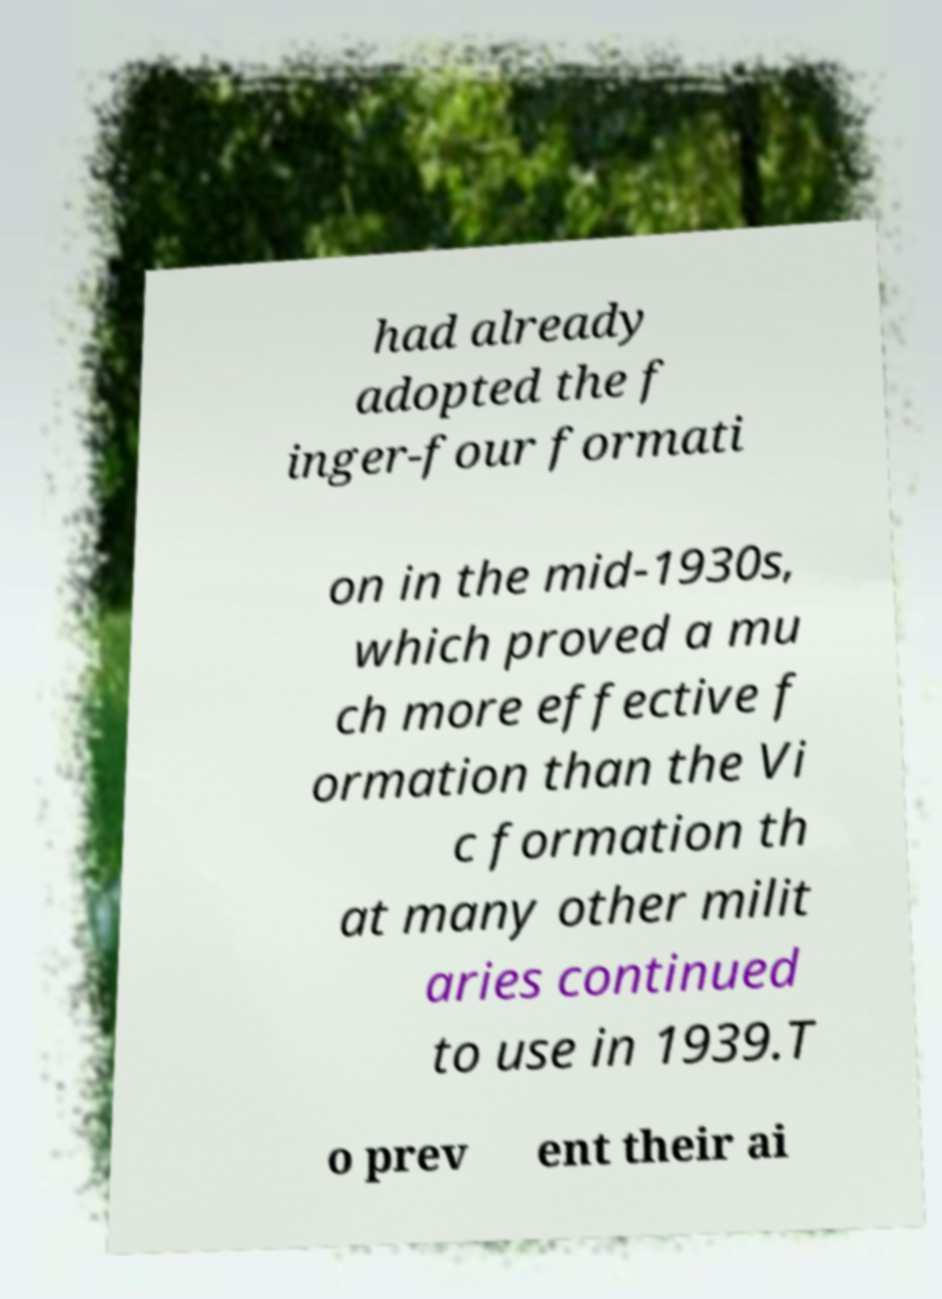What messages or text are displayed in this image? I need them in a readable, typed format. had already adopted the f inger-four formati on in the mid-1930s, which proved a mu ch more effective f ormation than the Vi c formation th at many other milit aries continued to use in 1939.T o prev ent their ai 